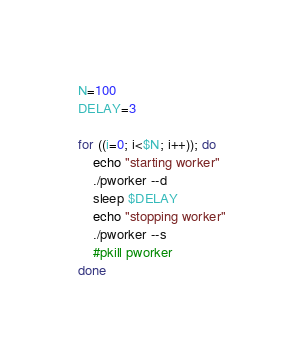Convert code to text. <code><loc_0><loc_0><loc_500><loc_500><_Bash_>
N=100
DELAY=3

for ((i=0; i<$N; i++)); do
    echo "starting worker"
    ./pworker --d
    sleep $DELAY
    echo "stopping worker"
    ./pworker --s
    #pkill pworker
done
</code> 